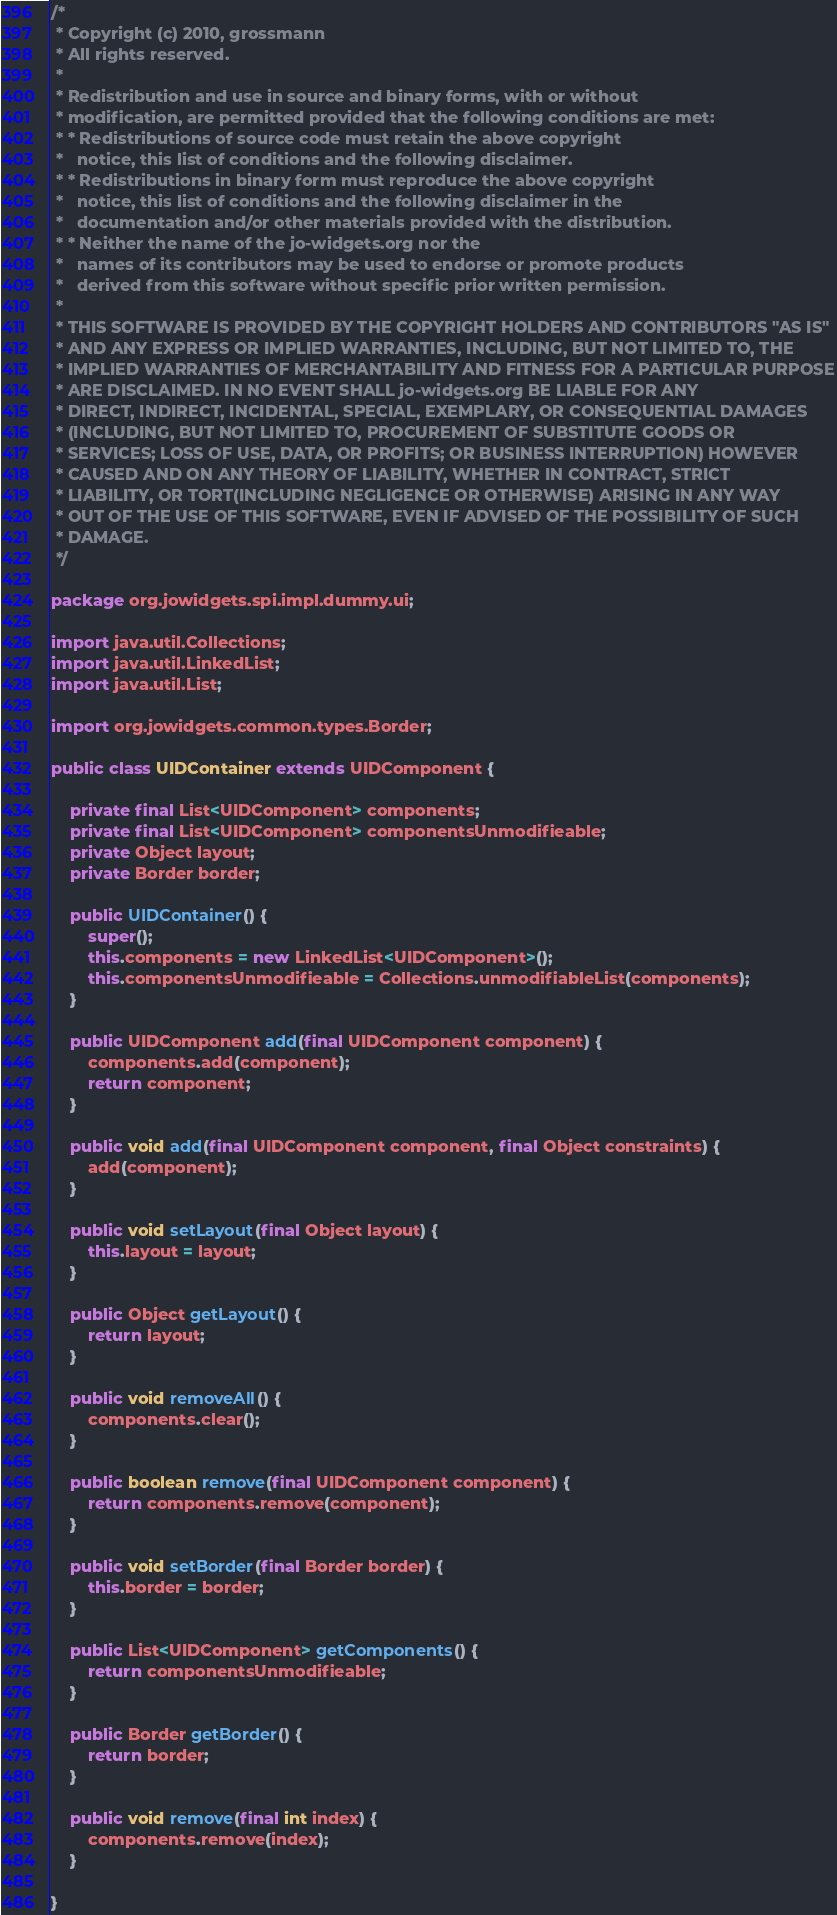<code> <loc_0><loc_0><loc_500><loc_500><_Java_>/*
 * Copyright (c) 2010, grossmann
 * All rights reserved.
 * 
 * Redistribution and use in source and binary forms, with or without
 * modification, are permitted provided that the following conditions are met:
 * * Redistributions of source code must retain the above copyright
 *   notice, this list of conditions and the following disclaimer.
 * * Redistributions in binary form must reproduce the above copyright
 *   notice, this list of conditions and the following disclaimer in the
 *   documentation and/or other materials provided with the distribution.
 * * Neither the name of the jo-widgets.org nor the
 *   names of its contributors may be used to endorse or promote products
 *   derived from this software without specific prior written permission.
 * 
 * THIS SOFTWARE IS PROVIDED BY THE COPYRIGHT HOLDERS AND CONTRIBUTORS "AS IS"
 * AND ANY EXPRESS OR IMPLIED WARRANTIES, INCLUDING, BUT NOT LIMITED TO, THE
 * IMPLIED WARRANTIES OF MERCHANTABILITY AND FITNESS FOR A PARTICULAR PURPOSE
 * ARE DISCLAIMED. IN NO EVENT SHALL jo-widgets.org BE LIABLE FOR ANY
 * DIRECT, INDIRECT, INCIDENTAL, SPECIAL, EXEMPLARY, OR CONSEQUENTIAL DAMAGES
 * (INCLUDING, BUT NOT LIMITED TO, PROCUREMENT OF SUBSTITUTE GOODS OR
 * SERVICES; LOSS OF USE, DATA, OR PROFITS; OR BUSINESS INTERRUPTION) HOWEVER
 * CAUSED AND ON ANY THEORY OF LIABILITY, WHETHER IN CONTRACT, STRICT
 * LIABILITY, OR TORT(INCLUDING NEGLIGENCE OR OTHERWISE) ARISING IN ANY WAY
 * OUT OF THE USE OF THIS SOFTWARE, EVEN IF ADVISED OF THE POSSIBILITY OF SUCH
 * DAMAGE.
 */

package org.jowidgets.spi.impl.dummy.ui;

import java.util.Collections;
import java.util.LinkedList;
import java.util.List;

import org.jowidgets.common.types.Border;

public class UIDContainer extends UIDComponent {

    private final List<UIDComponent> components;
    private final List<UIDComponent> componentsUnmodifieable;
    private Object layout;
    private Border border;

    public UIDContainer() {
        super();
        this.components = new LinkedList<UIDComponent>();
        this.componentsUnmodifieable = Collections.unmodifiableList(components);
    }

    public UIDComponent add(final UIDComponent component) {
        components.add(component);
        return component;
    }

    public void add(final UIDComponent component, final Object constraints) {
        add(component);
    }

    public void setLayout(final Object layout) {
        this.layout = layout;
    }

    public Object getLayout() {
        return layout;
    }

    public void removeAll() {
        components.clear();
    }

    public boolean remove(final UIDComponent component) {
        return components.remove(component);
    }

    public void setBorder(final Border border) {
        this.border = border;
    }

    public List<UIDComponent> getComponents() {
        return componentsUnmodifieable;
    }

    public Border getBorder() {
        return border;
    }

    public void remove(final int index) {
        components.remove(index);
    }

}
</code> 